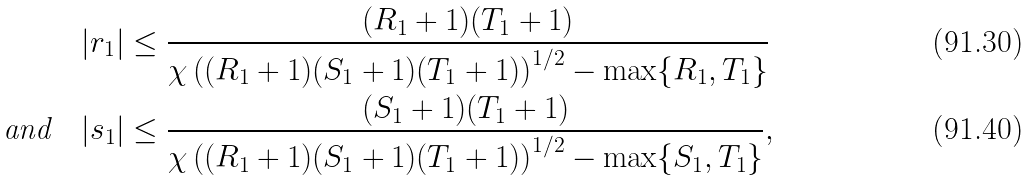Convert formula to latex. <formula><loc_0><loc_0><loc_500><loc_500>| r _ { 1 } | & \leq \frac { ( R _ { 1 } + 1 ) ( T _ { 1 } + 1 ) } { \chi \left ( ( R _ { 1 } + 1 ) ( S _ { 1 } + 1 ) ( T _ { 1 } + 1 ) \right ) ^ { 1 / 2 } - \max \{ R _ { 1 } , T _ { 1 } \} } \\ \text {and} \quad | s _ { 1 } | & \leq \frac { ( S _ { 1 } + 1 ) ( T _ { 1 } + 1 ) } { \chi \left ( ( R _ { 1 } + 1 ) ( S _ { 1 } + 1 ) ( T _ { 1 } + 1 ) \right ) ^ { 1 / 2 } - \max \{ S _ { 1 } , T _ { 1 } \} } ,</formula> 